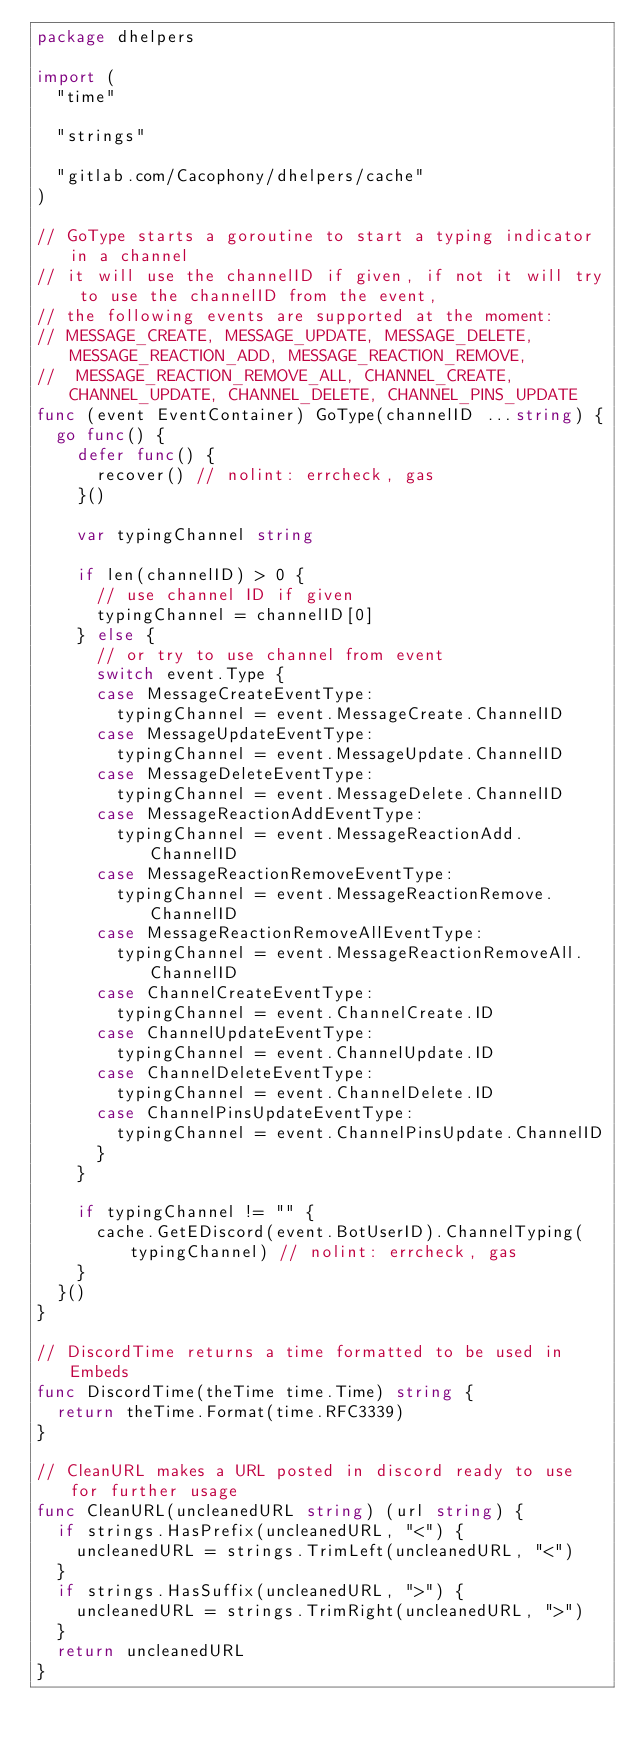Convert code to text. <code><loc_0><loc_0><loc_500><loc_500><_Go_>package dhelpers

import (
	"time"

	"strings"

	"gitlab.com/Cacophony/dhelpers/cache"
)

// GoType starts a goroutine to start a typing indicator in a channel
// it will use the channelID if given, if not it will try to use the channelID from the event,
// the following events are supported at the moment:
// MESSAGE_CREATE, MESSAGE_UPDATE, MESSAGE_DELETE, MESSAGE_REACTION_ADD, MESSAGE_REACTION_REMOVE,
//  MESSAGE_REACTION_REMOVE_ALL, CHANNEL_CREATE, CHANNEL_UPDATE, CHANNEL_DELETE, CHANNEL_PINS_UPDATE
func (event EventContainer) GoType(channelID ...string) {
	go func() {
		defer func() {
			recover() // nolint: errcheck, gas
		}()

		var typingChannel string

		if len(channelID) > 0 {
			// use channel ID if given
			typingChannel = channelID[0]
		} else {
			// or try to use channel from event
			switch event.Type {
			case MessageCreateEventType:
				typingChannel = event.MessageCreate.ChannelID
			case MessageUpdateEventType:
				typingChannel = event.MessageUpdate.ChannelID
			case MessageDeleteEventType:
				typingChannel = event.MessageDelete.ChannelID
			case MessageReactionAddEventType:
				typingChannel = event.MessageReactionAdd.ChannelID
			case MessageReactionRemoveEventType:
				typingChannel = event.MessageReactionRemove.ChannelID
			case MessageReactionRemoveAllEventType:
				typingChannel = event.MessageReactionRemoveAll.ChannelID
			case ChannelCreateEventType:
				typingChannel = event.ChannelCreate.ID
			case ChannelUpdateEventType:
				typingChannel = event.ChannelUpdate.ID
			case ChannelDeleteEventType:
				typingChannel = event.ChannelDelete.ID
			case ChannelPinsUpdateEventType:
				typingChannel = event.ChannelPinsUpdate.ChannelID
			}
		}

		if typingChannel != "" {
			cache.GetEDiscord(event.BotUserID).ChannelTyping(typingChannel) // nolint: errcheck, gas
		}
	}()
}

// DiscordTime returns a time formatted to be used in Embeds
func DiscordTime(theTime time.Time) string {
	return theTime.Format(time.RFC3339)
}

// CleanURL makes a URL posted in discord ready to use for further usage
func CleanURL(uncleanedURL string) (url string) {
	if strings.HasPrefix(uncleanedURL, "<") {
		uncleanedURL = strings.TrimLeft(uncleanedURL, "<")
	}
	if strings.HasSuffix(uncleanedURL, ">") {
		uncleanedURL = strings.TrimRight(uncleanedURL, ">")
	}
	return uncleanedURL
}
</code> 